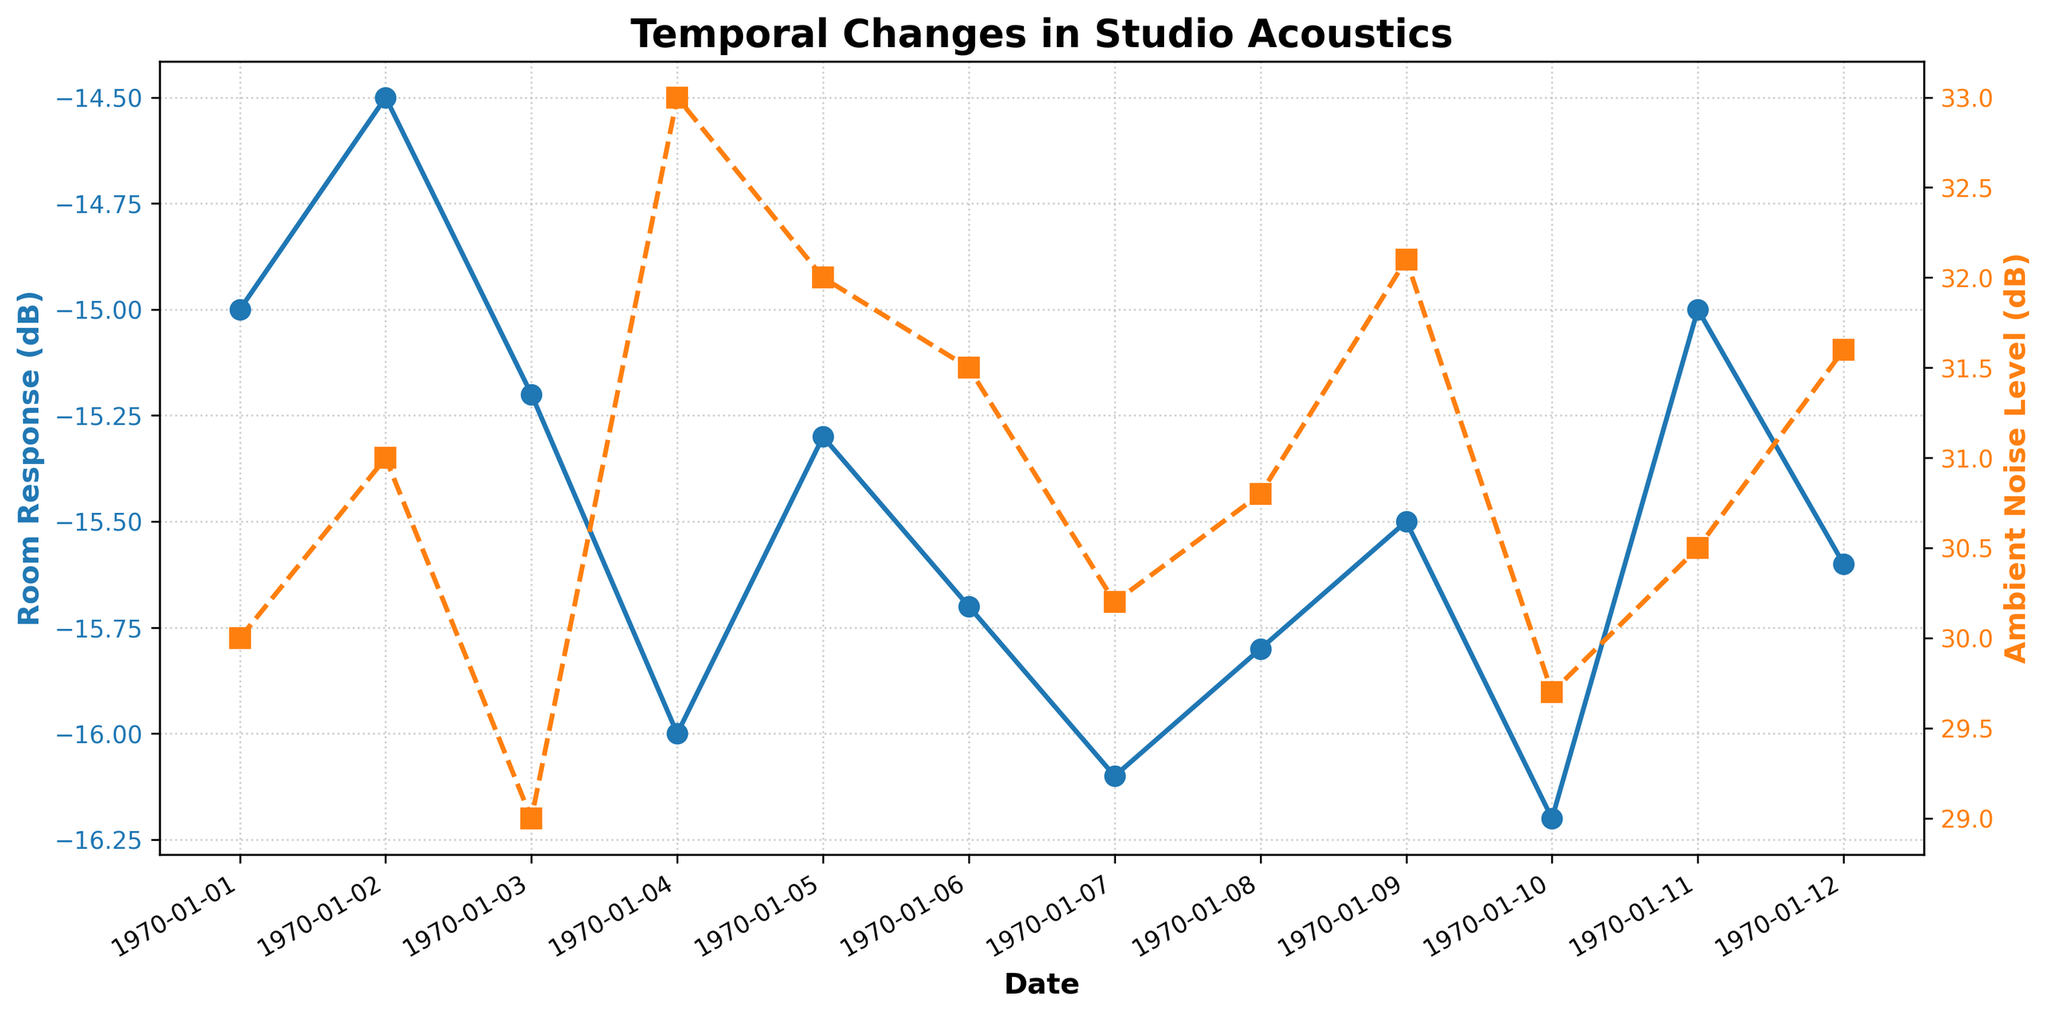What is the title of the figure? The title is located at the top of the figure and is displayed prominently in bold text.
Answer: Temporal Changes in Studio Acoustics What are the colors of the lines representing Room Response and Ambient Noise Level? The color for Room Response is blue, and the color for Ambient Noise Level is orange. These colors correspond to their respective labels.
Answer: blue and orange How does Room Response (dB) change from January 1st to January 4th? From January 1st to January 4th, the Room Response (dB) decreases from -15 dB to -16 dB. This can be seen by following the blue line from left to right.
Answer: decreases by 1 dB What is the Ambient Noise Level (dB) on January 5th? To find the Ambient Noise Level on January 5th, locate the orange line on the x-axis mark for January 5th, which is labeled as 32 dB.
Answer: 32 dB Which day records the lowest Room Response (dB)? The lowest Room Response (dB) is noted on January 10th and January 12th, reaching -16.2 dB. This is the lowest point on the blue line.
Answer: January 10th and January 12th By how much did the Ambient Noise Level (dB) increase from January 3rd to January 4th? The Ambient Noise Level recorded on January 3rd is 29 dB, and it increases to 33 dB on January 4th. The difference between these values is 33 - 29.
Answer: 4 dB On which day did the Ambient Noise Level (dB) exceed Room Response (dB) value the most? By examining the graph, the largest difference where the orange line (Ambient Noise) exceeds the blue line (Room Response) occurs on January 4th.
Answer: January 4th What is the overall trend of Room Response (dB) over the observed period? Analyzing the blue line from left to right, Room Response (dB) generally exhibits a slight decline, showing a downward trend over time.
Answer: decreasing trend Is there any day where both Room Response (dB) and Ambient Noise Level (dB) moved in the opposite direction simultaneously? If so, which day? On January 3rd, Room Response (dB) decreases while Ambient Noise Level (dB) also decreases, indicating they did not move in opposite directions.
Answer: No What is the average Ambient Noise Level (dB) over the entire period? The sum of Ambient Noise Levels over all days is 381.1 dB. Dividing this by the number of days (12) gives 31.758 dB.
Answer: 31.758 dB 